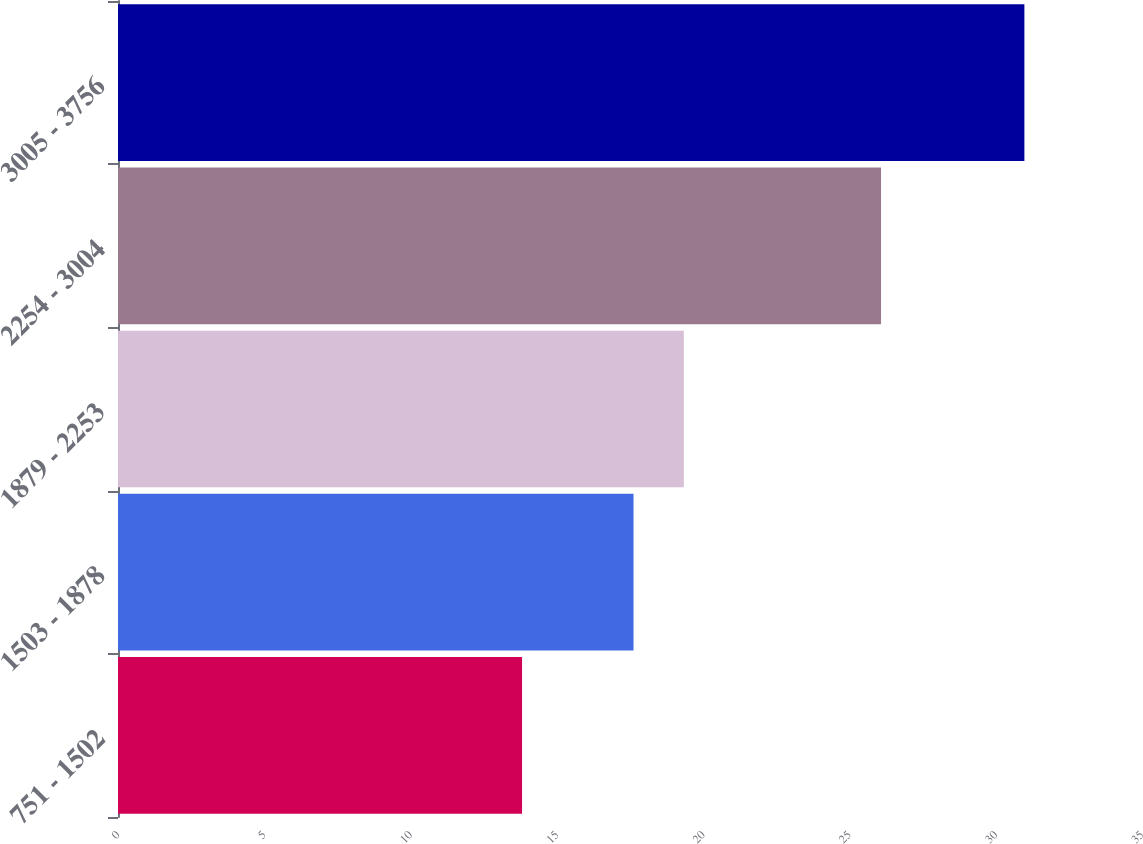Convert chart. <chart><loc_0><loc_0><loc_500><loc_500><bar_chart><fcel>751 - 1502<fcel>1503 - 1878<fcel>1879 - 2253<fcel>2254 - 3004<fcel>3005 - 3756<nl><fcel>13.81<fcel>17.62<fcel>19.34<fcel>26.08<fcel>30.98<nl></chart> 